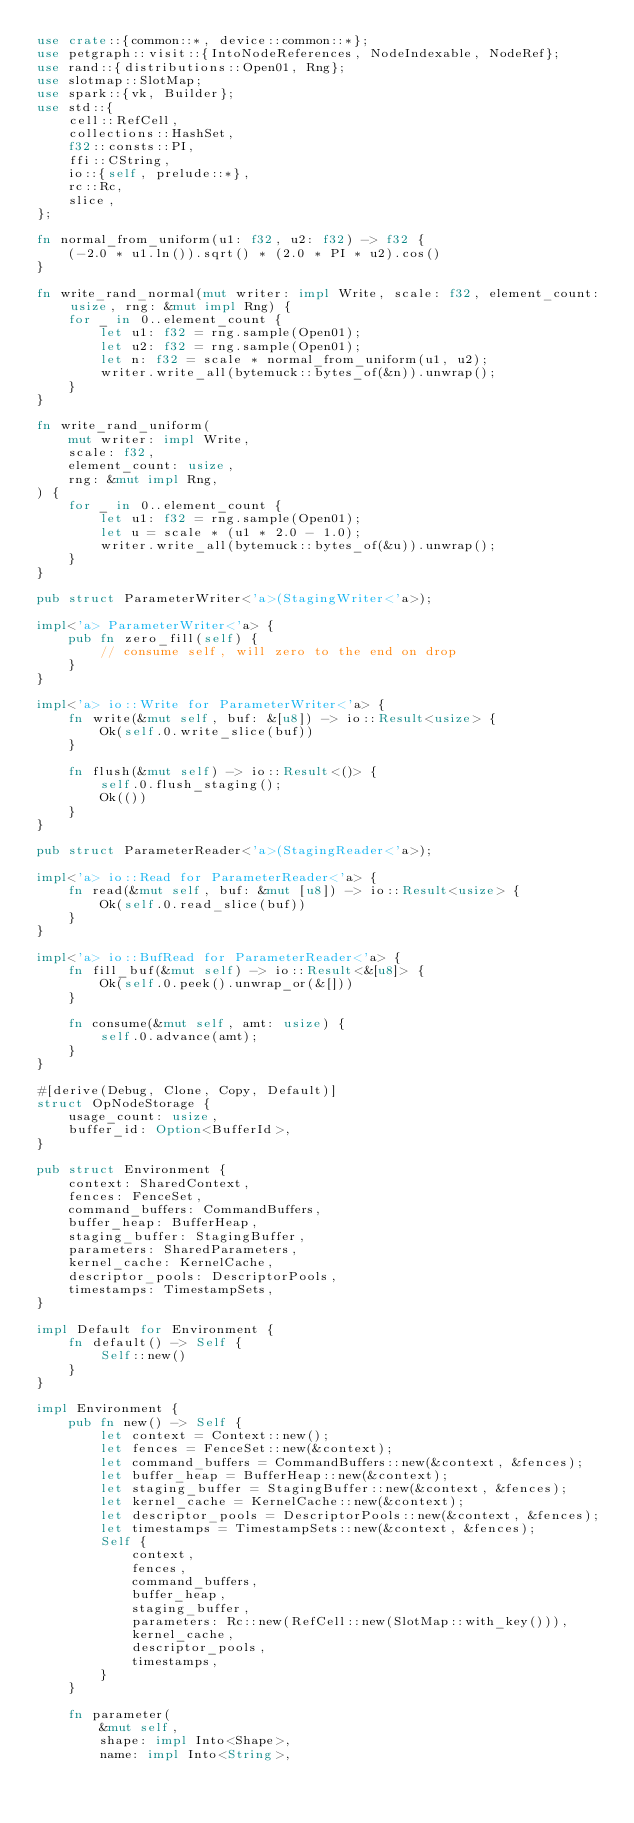<code> <loc_0><loc_0><loc_500><loc_500><_Rust_>use crate::{common::*, device::common::*};
use petgraph::visit::{IntoNodeReferences, NodeIndexable, NodeRef};
use rand::{distributions::Open01, Rng};
use slotmap::SlotMap;
use spark::{vk, Builder};
use std::{
    cell::RefCell,
    collections::HashSet,
    f32::consts::PI,
    ffi::CString,
    io::{self, prelude::*},
    rc::Rc,
    slice,
};

fn normal_from_uniform(u1: f32, u2: f32) -> f32 {
    (-2.0 * u1.ln()).sqrt() * (2.0 * PI * u2).cos()
}

fn write_rand_normal(mut writer: impl Write, scale: f32, element_count: usize, rng: &mut impl Rng) {
    for _ in 0..element_count {
        let u1: f32 = rng.sample(Open01);
        let u2: f32 = rng.sample(Open01);
        let n: f32 = scale * normal_from_uniform(u1, u2);
        writer.write_all(bytemuck::bytes_of(&n)).unwrap();
    }
}

fn write_rand_uniform(
    mut writer: impl Write,
    scale: f32,
    element_count: usize,
    rng: &mut impl Rng,
) {
    for _ in 0..element_count {
        let u1: f32 = rng.sample(Open01);
        let u = scale * (u1 * 2.0 - 1.0);
        writer.write_all(bytemuck::bytes_of(&u)).unwrap();
    }
}

pub struct ParameterWriter<'a>(StagingWriter<'a>);

impl<'a> ParameterWriter<'a> {
    pub fn zero_fill(self) {
        // consume self, will zero to the end on drop
    }
}

impl<'a> io::Write for ParameterWriter<'a> {
    fn write(&mut self, buf: &[u8]) -> io::Result<usize> {
        Ok(self.0.write_slice(buf))
    }

    fn flush(&mut self) -> io::Result<()> {
        self.0.flush_staging();
        Ok(())
    }
}

pub struct ParameterReader<'a>(StagingReader<'a>);

impl<'a> io::Read for ParameterReader<'a> {
    fn read(&mut self, buf: &mut [u8]) -> io::Result<usize> {
        Ok(self.0.read_slice(buf))
    }
}

impl<'a> io::BufRead for ParameterReader<'a> {
    fn fill_buf(&mut self) -> io::Result<&[u8]> {
        Ok(self.0.peek().unwrap_or(&[]))
    }

    fn consume(&mut self, amt: usize) {
        self.0.advance(amt);
    }
}

#[derive(Debug, Clone, Copy, Default)]
struct OpNodeStorage {
    usage_count: usize,
    buffer_id: Option<BufferId>,
}

pub struct Environment {
    context: SharedContext,
    fences: FenceSet,
    command_buffers: CommandBuffers,
    buffer_heap: BufferHeap,
    staging_buffer: StagingBuffer,
    parameters: SharedParameters,
    kernel_cache: KernelCache,
    descriptor_pools: DescriptorPools,
    timestamps: TimestampSets,
}

impl Default for Environment {
    fn default() -> Self {
        Self::new()
    }
}

impl Environment {
    pub fn new() -> Self {
        let context = Context::new();
        let fences = FenceSet::new(&context);
        let command_buffers = CommandBuffers::new(&context, &fences);
        let buffer_heap = BufferHeap::new(&context);
        let staging_buffer = StagingBuffer::new(&context, &fences);
        let kernel_cache = KernelCache::new(&context);
        let descriptor_pools = DescriptorPools::new(&context, &fences);
        let timestamps = TimestampSets::new(&context, &fences);
        Self {
            context,
            fences,
            command_buffers,
            buffer_heap,
            staging_buffer,
            parameters: Rc::new(RefCell::new(SlotMap::with_key())),
            kernel_cache,
            descriptor_pools,
            timestamps,
        }
    }

    fn parameter(
        &mut self,
        shape: impl Into<Shape>,
        name: impl Into<String>,</code> 